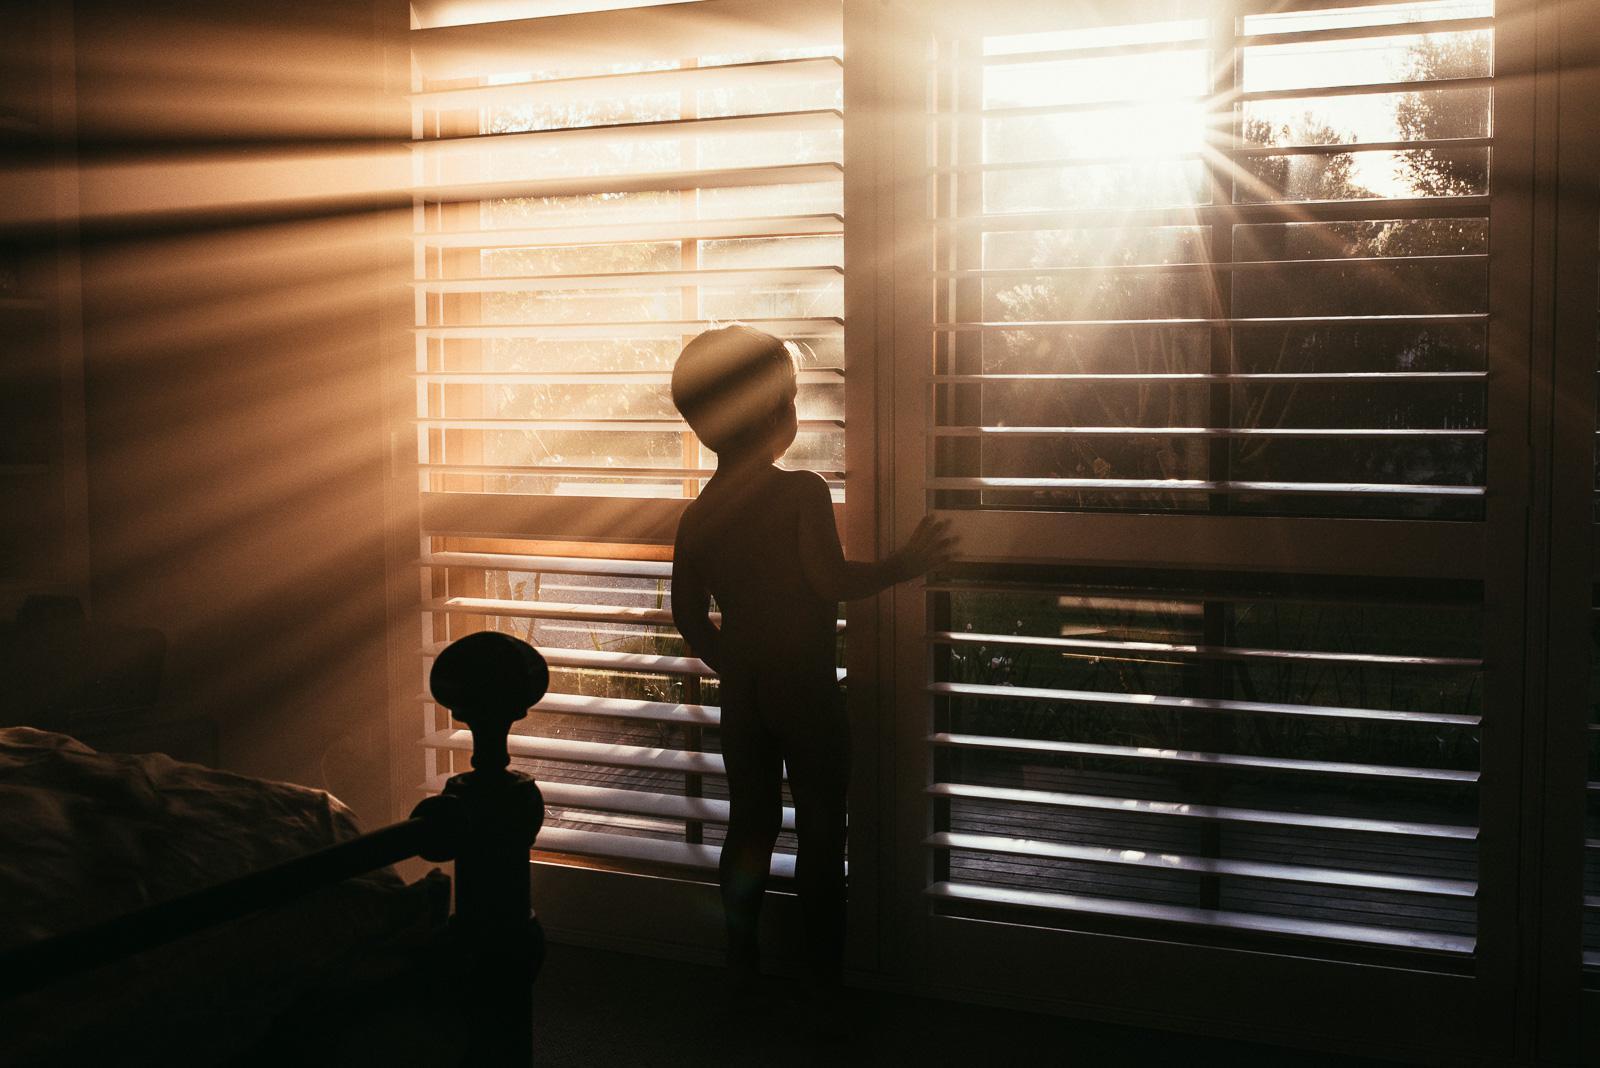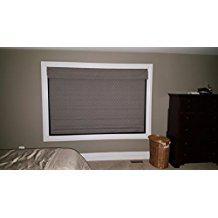The first image is the image on the left, the second image is the image on the right. Considering the images on both sides, is "A window shade is partially pulled up in the right image." valid? Answer yes or no. No. The first image is the image on the left, the second image is the image on the right. Considering the images on both sides, is "There are five blinds." valid? Answer yes or no. No. 